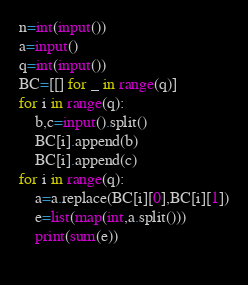<code> <loc_0><loc_0><loc_500><loc_500><_Python_>n=int(input())
a=input()
q=int(input())
BC=[[] for _ in range(q)]
for i in range(q):
    b,c=input().split()
    BC[i].append(b)
    BC[i].append(c)
for i in range(q):
    a=a.replace(BC[i][0],BC[i][1])
    e=list(map(int,a.split()))
    print(sum(e))
        </code> 